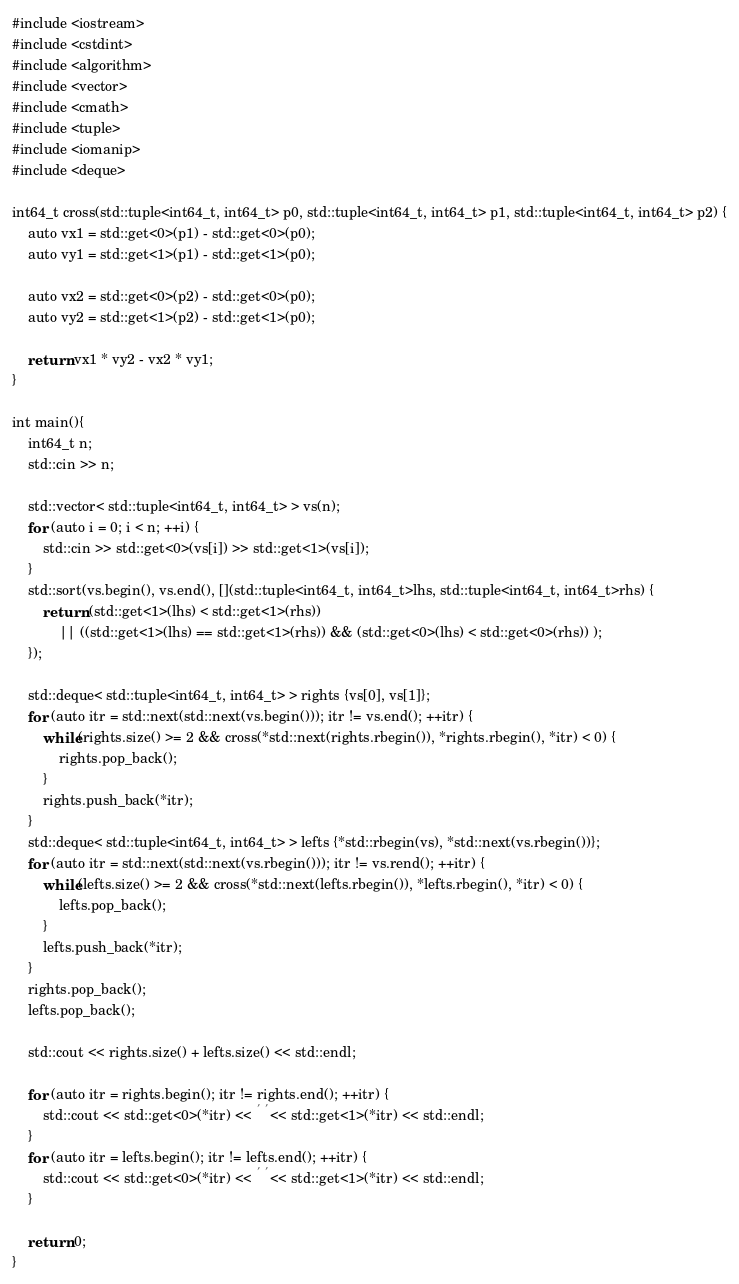Convert code to text. <code><loc_0><loc_0><loc_500><loc_500><_Scala_>#include <iostream>
#include <cstdint>
#include <algorithm>
#include <vector>
#include <cmath>
#include <tuple>
#include <iomanip>
#include <deque>

int64_t cross(std::tuple<int64_t, int64_t> p0, std::tuple<int64_t, int64_t> p1, std::tuple<int64_t, int64_t> p2) {
    auto vx1 = std::get<0>(p1) - std::get<0>(p0);
    auto vy1 = std::get<1>(p1) - std::get<1>(p0);

    auto vx2 = std::get<0>(p2) - std::get<0>(p0);
    auto vy2 = std::get<1>(p2) - std::get<1>(p0);

    return vx1 * vy2 - vx2 * vy1;
}

int main(){
    int64_t n;
    std::cin >> n;

    std::vector< std::tuple<int64_t, int64_t> > vs(n);
    for (auto i = 0; i < n; ++i) {
        std::cin >> std::get<0>(vs[i]) >> std::get<1>(vs[i]);
    }
    std::sort(vs.begin(), vs.end(), [](std::tuple<int64_t, int64_t>lhs, std::tuple<int64_t, int64_t>rhs) {
        return (std::get<1>(lhs) < std::get<1>(rhs))
            || ((std::get<1>(lhs) == std::get<1>(rhs)) && (std::get<0>(lhs) < std::get<0>(rhs)) );
    });

    std::deque< std::tuple<int64_t, int64_t> > rights {vs[0], vs[1]};
    for (auto itr = std::next(std::next(vs.begin())); itr != vs.end(); ++itr) {
        while(rights.size() >= 2 && cross(*std::next(rights.rbegin()), *rights.rbegin(), *itr) < 0) {
            rights.pop_back();
        }
        rights.push_back(*itr);
    }
    std::deque< std::tuple<int64_t, int64_t> > lefts {*std::rbegin(vs), *std::next(vs.rbegin())};
    for (auto itr = std::next(std::next(vs.rbegin())); itr != vs.rend(); ++itr) {
        while(lefts.size() >= 2 && cross(*std::next(lefts.rbegin()), *lefts.rbegin(), *itr) < 0) {
            lefts.pop_back();
        }
        lefts.push_back(*itr);
    }
    rights.pop_back();
    lefts.pop_back();
    
    std::cout << rights.size() + lefts.size() << std::endl;

    for (auto itr = rights.begin(); itr != rights.end(); ++itr) {
        std::cout << std::get<0>(*itr) << ' ' << std::get<1>(*itr) << std::endl;
    }
    for (auto itr = lefts.begin(); itr != lefts.end(); ++itr) {
        std::cout << std::get<0>(*itr) << ' ' << std::get<1>(*itr) << std::endl;
    }

    return 0;
}
</code> 